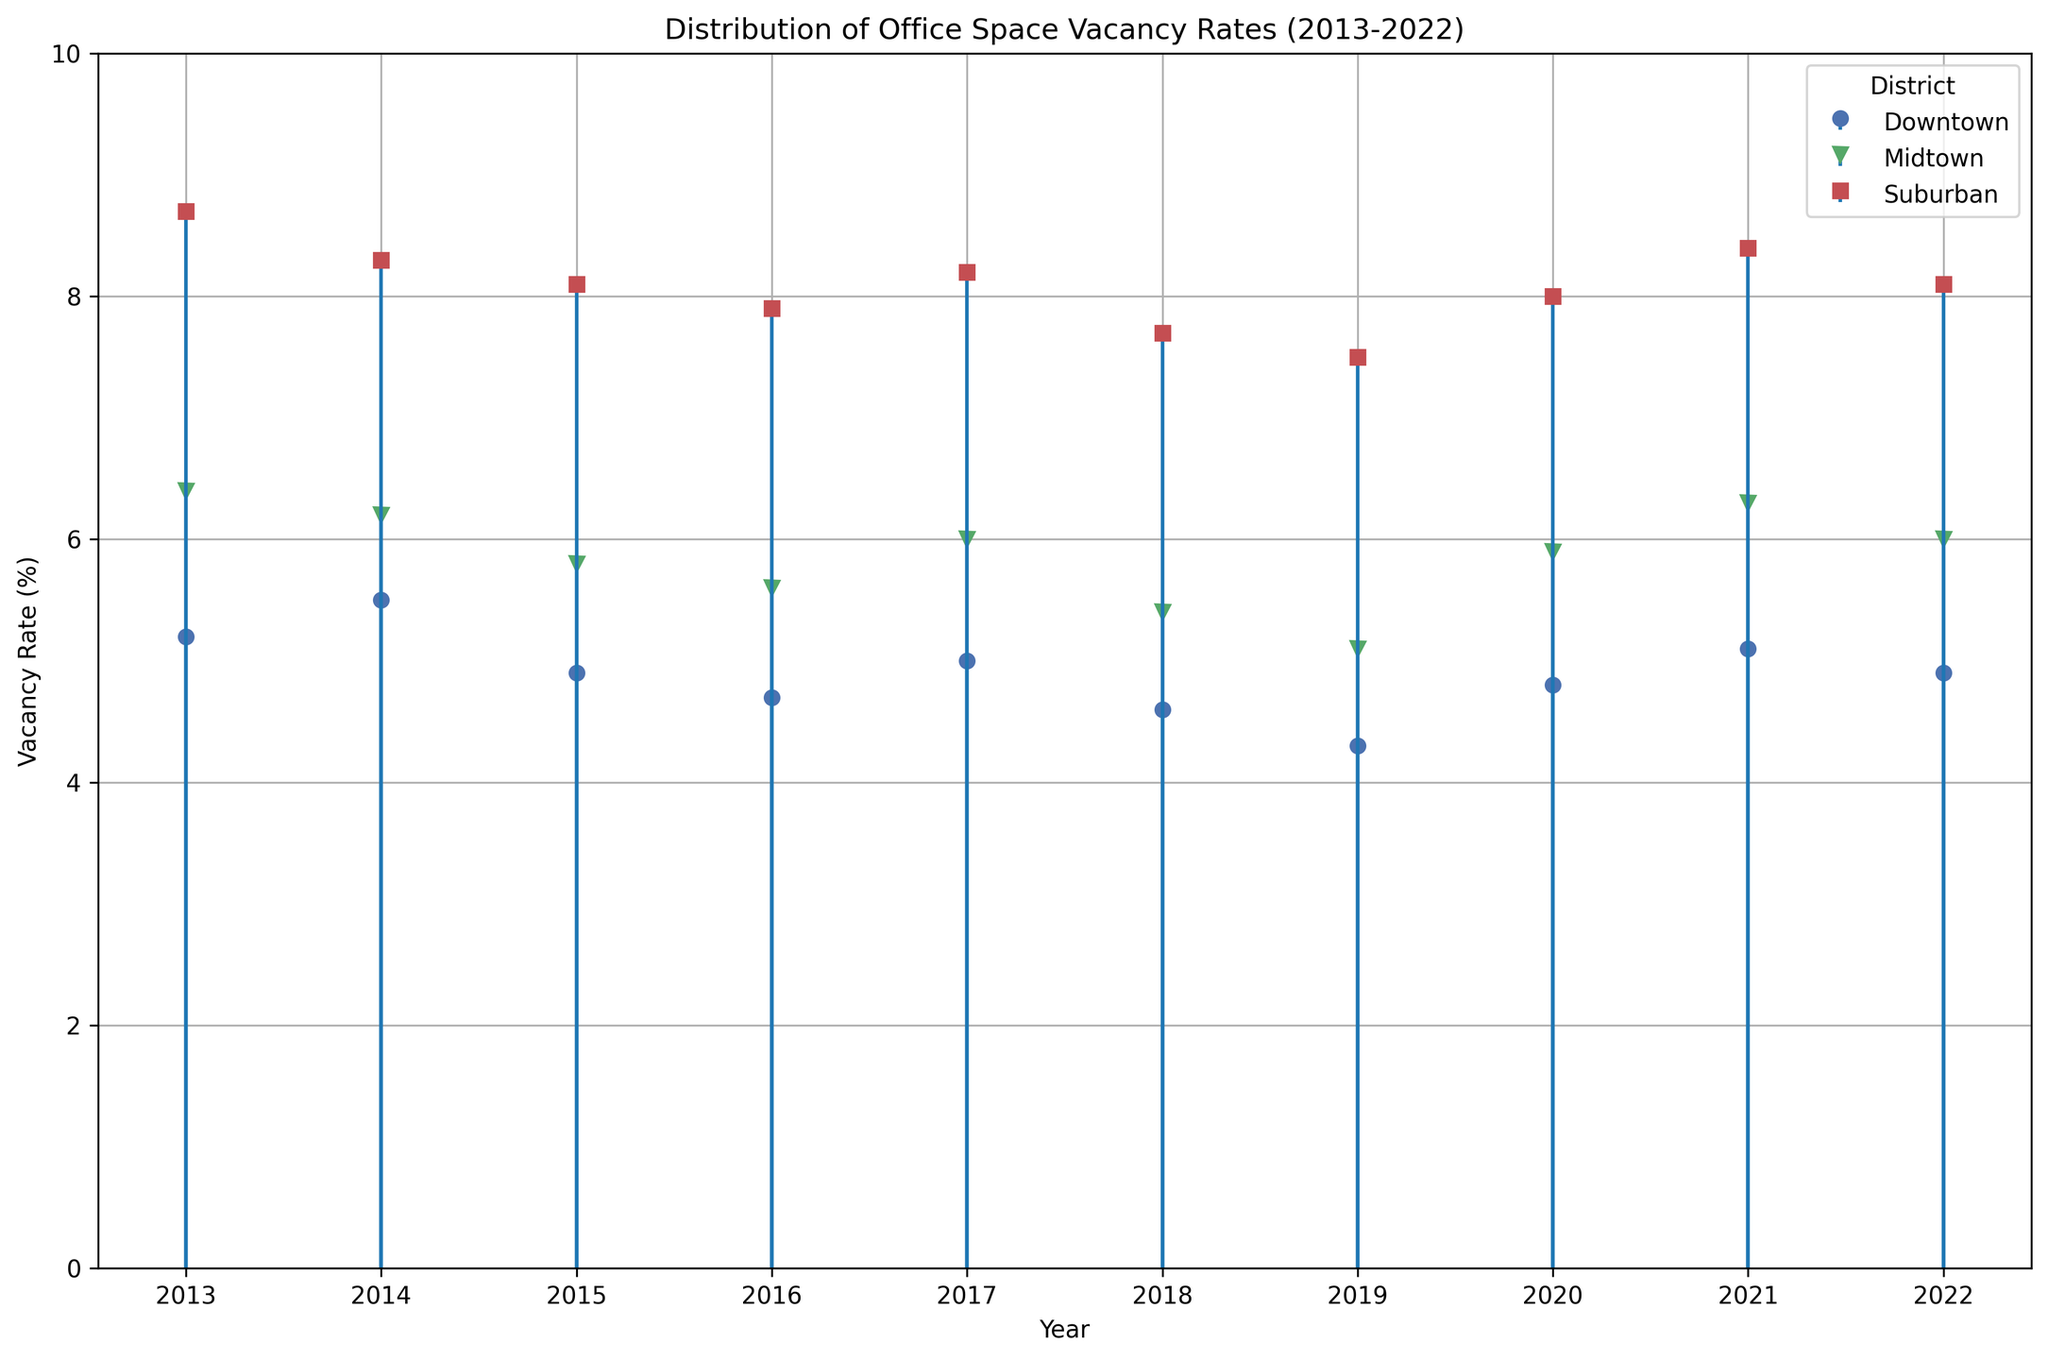What was the vacancy rate in Downtown in 2016? Locate the 'Downtown' series on the graph, find the year 2016, then read the corresponding vacancy rate.
Answer: 4.7% Which district had the highest vacancy rate on the graph in 2018? Compare the vacancy rates for all three districts (Downtown, Midtown, Suburban) in 2018 and find the highest one.
Answer: Suburban What are the average vacancy rates for Downtown and Midtown across all the years shown? Sum all vacancy rates for Downtown and Midtown from 2013 to 2022, respectively. Then, divide each sum by the number of years (10) to calculate the averages.
Answer: Downtown: 4.8%, Midtown: 5.9% Which year had the lowest vacancy rate for Suburban? Look at the 'Suburban' series and find the year with the lowest stem along the y-axis to identify the lowest vacancy rate.
Answer: 2019 How does the vacancy rate in Downtown compare to Midtown in 2020? Find the vacancy rates for both Downtown and Midtown in 2020 and compare the two values.
Answer: Downtown: 4.8%, Midtown: 5.9% By how much did the vacancy rate in Downtown decrease from 2014 to 2019? Subtract the vacancy rate in 2019 from the rate in 2014 for the Downtown series to determine the decrease.
Answer: 5.5% - 4.3% = 1.2% What is the general trend for Midtown's vacancy rates over the decade? Observe the general movement of the stems for Midtown from 2013 to 2022 to describe whether it increases, decreases or remains stable.
Answer: Generally decreasing Which year shows the highest increase in vacancy rate for any district compared to the previous year? Compare the year-over-year changes in vacancy rates for all districts and identify the highest positive change.
Answer: 2014 for Downtown How many times did the vacancy rate in Suburban go above 8% during the decade? Count the number of years where Suburban's vacancy rate is plotted above the 8% mark on the y-axis.
Answer: 5 times 